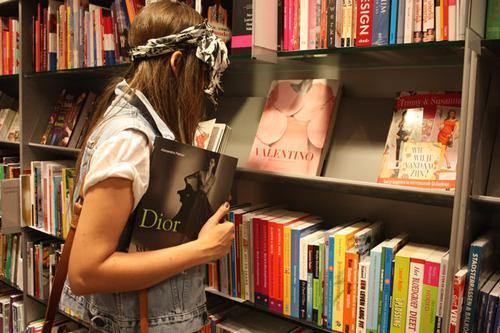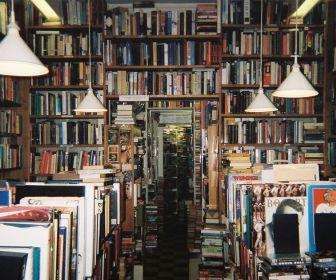The first image is the image on the left, the second image is the image on the right. Assess this claim about the two images: "Both images show large collections of books and no people can be seen in either.". Correct or not? Answer yes or no. No. The first image is the image on the left, the second image is the image on the right. Considering the images on both sides, is "There is a person looking at a book." valid? Answer yes or no. Yes. 